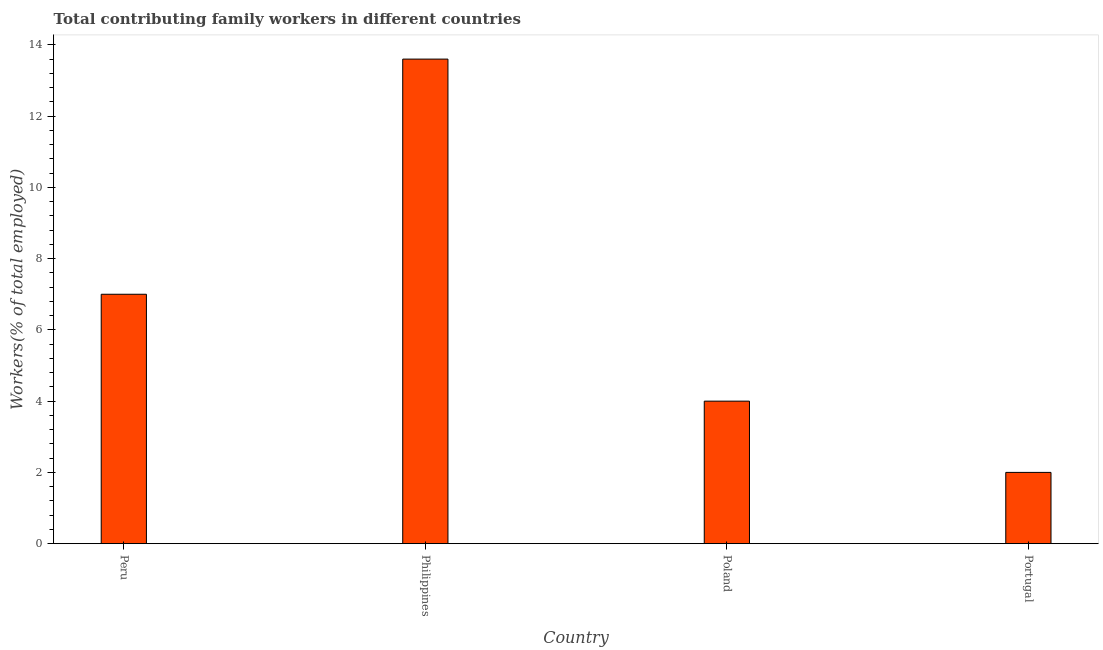Does the graph contain any zero values?
Your answer should be very brief. No. Does the graph contain grids?
Your answer should be very brief. No. What is the title of the graph?
Your response must be concise. Total contributing family workers in different countries. What is the label or title of the X-axis?
Ensure brevity in your answer.  Country. What is the label or title of the Y-axis?
Keep it short and to the point. Workers(% of total employed). What is the contributing family workers in Peru?
Provide a short and direct response. 7. Across all countries, what is the maximum contributing family workers?
Your answer should be compact. 13.6. Across all countries, what is the minimum contributing family workers?
Offer a very short reply. 2. In which country was the contributing family workers minimum?
Give a very brief answer. Portugal. What is the sum of the contributing family workers?
Provide a succinct answer. 26.6. What is the average contributing family workers per country?
Make the answer very short. 6.65. What is the median contributing family workers?
Offer a very short reply. 5.5. What is the difference between the highest and the second highest contributing family workers?
Provide a short and direct response. 6.6. How many countries are there in the graph?
Keep it short and to the point. 4. What is the difference between two consecutive major ticks on the Y-axis?
Provide a succinct answer. 2. Are the values on the major ticks of Y-axis written in scientific E-notation?
Provide a succinct answer. No. What is the Workers(% of total employed) in Philippines?
Your response must be concise. 13.6. What is the Workers(% of total employed) of Portugal?
Your response must be concise. 2. What is the difference between the Workers(% of total employed) in Peru and Philippines?
Offer a very short reply. -6.6. What is the difference between the Workers(% of total employed) in Peru and Portugal?
Your answer should be compact. 5. What is the difference between the Workers(% of total employed) in Philippines and Poland?
Your response must be concise. 9.6. What is the difference between the Workers(% of total employed) in Philippines and Portugal?
Offer a very short reply. 11.6. What is the ratio of the Workers(% of total employed) in Peru to that in Philippines?
Your answer should be compact. 0.52. What is the ratio of the Workers(% of total employed) in Peru to that in Poland?
Ensure brevity in your answer.  1.75. What is the ratio of the Workers(% of total employed) in Peru to that in Portugal?
Provide a short and direct response. 3.5. What is the ratio of the Workers(% of total employed) in Philippines to that in Portugal?
Offer a terse response. 6.8. 